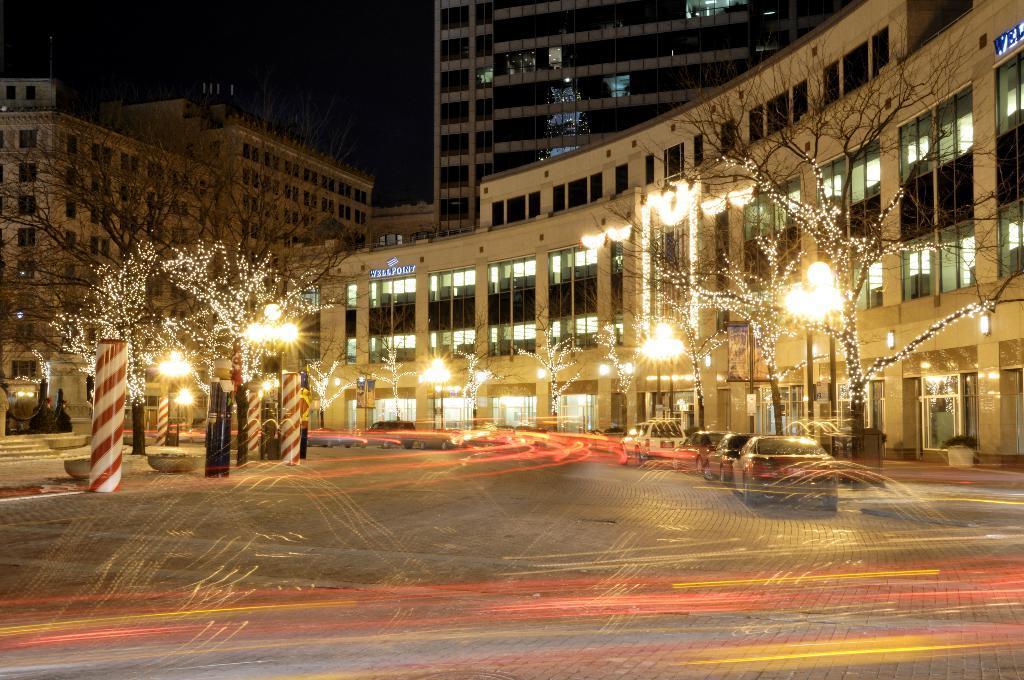Describe this image in one or two sentences. This image is taken during the night time. In this image we can see that there are so many buildings. In the middle there is a road on which there are vehicles. Beside the road there are trees on either side of the road. To the trees there are lights. There are poles on the footpath. 